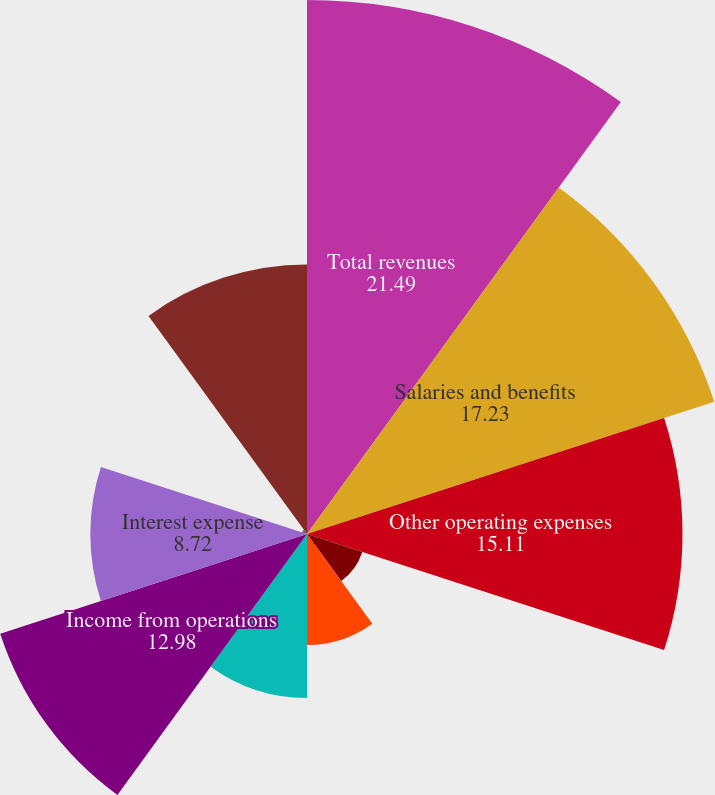Convert chart. <chart><loc_0><loc_0><loc_500><loc_500><pie_chart><fcel>Total revenues<fcel>Salaries and benefits<fcel>Other operating expenses<fcel>Depreciation<fcel>Amortization<fcel>Restructuring costs<fcel>Income from operations<fcel>Interest expense<fcel>(Benefit from)/provision for<fcel>NET INCOME ATTRIBUTABLE TO<nl><fcel>21.49%<fcel>17.23%<fcel>15.11%<fcel>2.34%<fcel>4.47%<fcel>6.6%<fcel>12.98%<fcel>8.72%<fcel>0.21%<fcel>10.85%<nl></chart> 